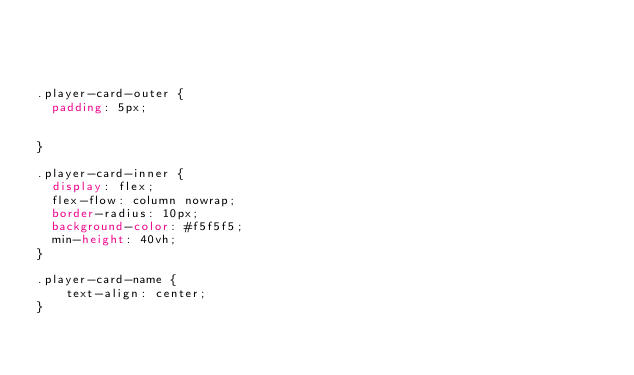<code> <loc_0><loc_0><loc_500><loc_500><_CSS_>



.player-card-outer {
  padding: 5px;


}

.player-card-inner {
  display: flex;
  flex-flow: column nowrap;
  border-radius: 10px;
  background-color: #f5f5f5;
  min-height: 40vh;
}

.player-card-name {
    text-align: center;
}
</code> 